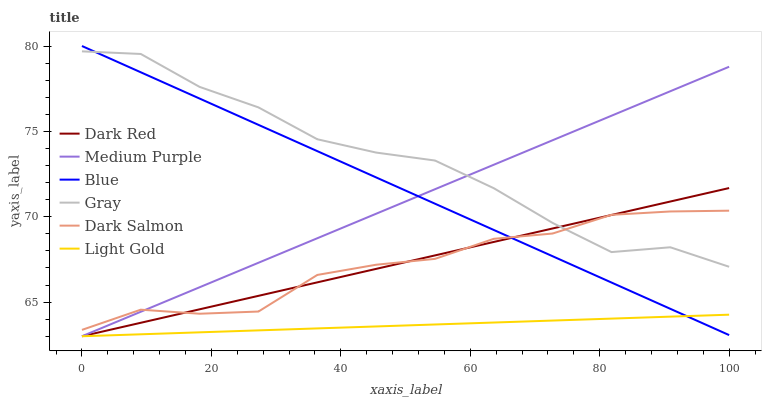Does Dark Red have the minimum area under the curve?
Answer yes or no. No. Does Dark Red have the maximum area under the curve?
Answer yes or no. No. Is Dark Red the smoothest?
Answer yes or no. No. Is Dark Red the roughest?
Answer yes or no. No. Does Gray have the lowest value?
Answer yes or no. No. Does Gray have the highest value?
Answer yes or no. No. Is Light Gold less than Dark Salmon?
Answer yes or no. Yes. Is Gray greater than Light Gold?
Answer yes or no. Yes. Does Light Gold intersect Dark Salmon?
Answer yes or no. No. 